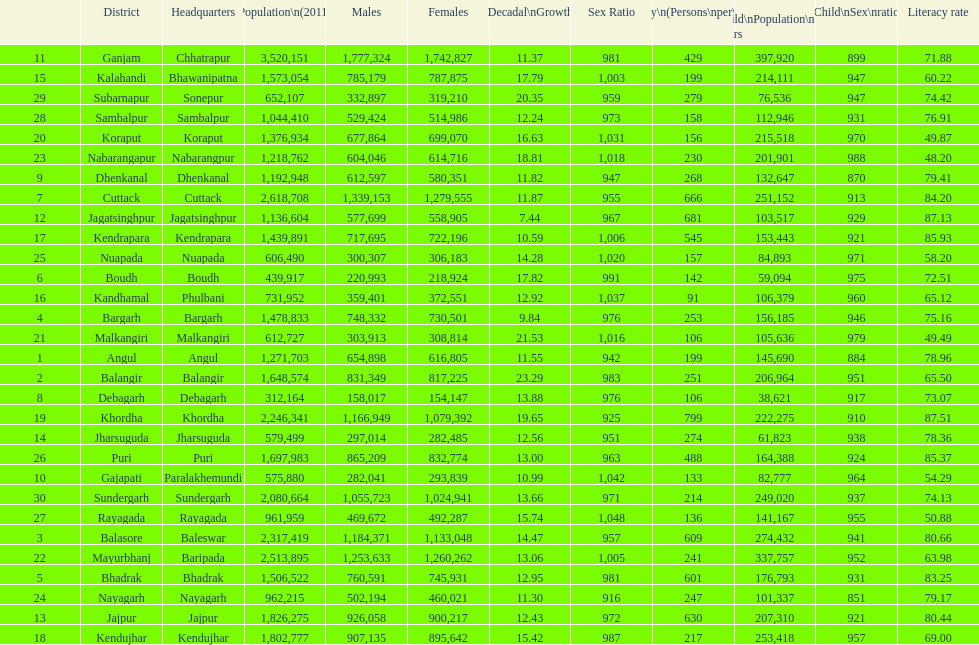Tell me a district that did not have a population over 600,000. Boudh. 